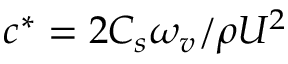Convert formula to latex. <formula><loc_0><loc_0><loc_500><loc_500>c ^ { * } = 2 C _ { s } \omega _ { v } / \rho U ^ { 2 }</formula> 